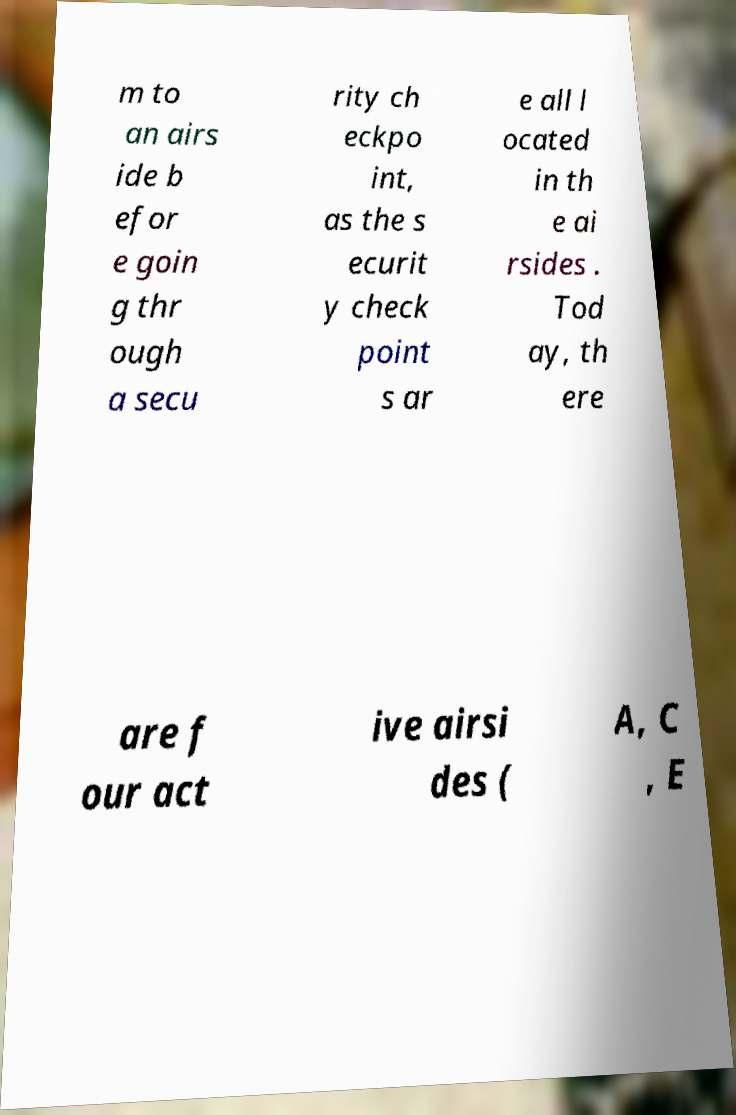For documentation purposes, I need the text within this image transcribed. Could you provide that? m to an airs ide b efor e goin g thr ough a secu rity ch eckpo int, as the s ecurit y check point s ar e all l ocated in th e ai rsides . Tod ay, th ere are f our act ive airsi des ( A, C , E 